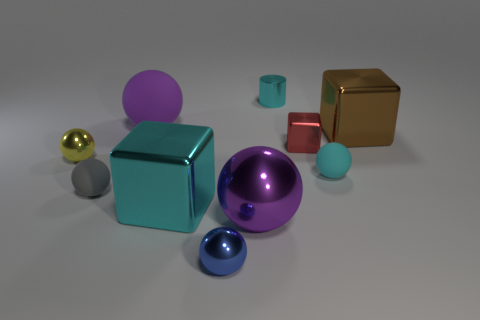How many objects are either small gray metal blocks or things that are behind the blue ball?
Provide a succinct answer. 9. What is the color of the big matte object?
Your answer should be very brief. Purple. What color is the big metal cube that is left of the tiny cyan cylinder?
Offer a terse response. Cyan. What number of metallic cylinders are in front of the big purple matte ball that is on the left side of the big purple metallic sphere?
Your response must be concise. 0. Does the red thing have the same size as the sphere on the left side of the small gray matte ball?
Ensure brevity in your answer.  Yes. Are there any gray things of the same size as the red block?
Give a very brief answer. Yes. How many objects are either red cubes or brown metallic blocks?
Your answer should be compact. 2. Do the purple object that is to the right of the big cyan block and the blue shiny sphere to the right of the tiny gray ball have the same size?
Make the answer very short. No. Are there any other tiny objects of the same shape as the brown metallic thing?
Provide a short and direct response. Yes. Is the number of red shiny things that are in front of the gray matte sphere less than the number of green shiny blocks?
Offer a very short reply. No. 